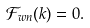Convert formula to latex. <formula><loc_0><loc_0><loc_500><loc_500>\mathcal { F } _ { w n } ( k ) = 0 .</formula> 